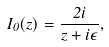Convert formula to latex. <formula><loc_0><loc_0><loc_500><loc_500>I _ { 0 } ( z ) = \frac { 2 i } { z + i \epsilon } ,</formula> 